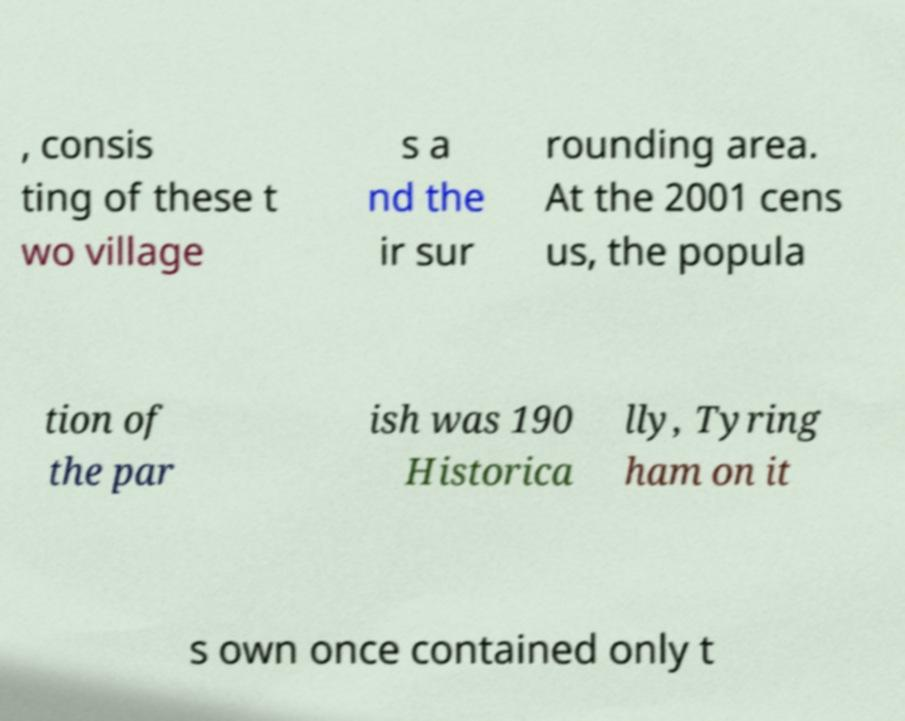Please identify and transcribe the text found in this image. , consis ting of these t wo village s a nd the ir sur rounding area. At the 2001 cens us, the popula tion of the par ish was 190 Historica lly, Tyring ham on it s own once contained only t 